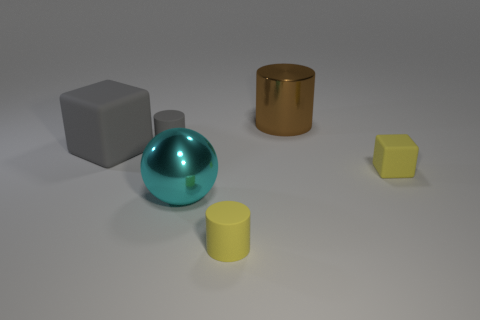How many small matte cylinders are the same color as the large rubber object?
Offer a terse response. 1. Is the shape of the small thing behind the big gray thing the same as  the large matte thing?
Offer a very short reply. No. Are there fewer small cubes that are in front of the small rubber cube than tiny yellow things that are left of the brown metallic cylinder?
Make the answer very short. Yes. What material is the big thing that is in front of the yellow matte block?
Your answer should be very brief. Metal. There is a matte cylinder that is the same color as the large block; what size is it?
Provide a succinct answer. Small. Are there any red blocks of the same size as the metallic cylinder?
Your answer should be very brief. No. Is the shape of the brown metallic object the same as the small yellow object that is on the left side of the brown metallic thing?
Offer a very short reply. Yes. Does the yellow matte object in front of the cyan metallic object have the same size as the yellow matte thing behind the yellow cylinder?
Offer a terse response. Yes. What number of other objects are there of the same shape as the big cyan metal thing?
Provide a short and direct response. 0. There is a cylinder that is in front of the shiny thing in front of the brown cylinder; what is it made of?
Your answer should be compact. Rubber. 